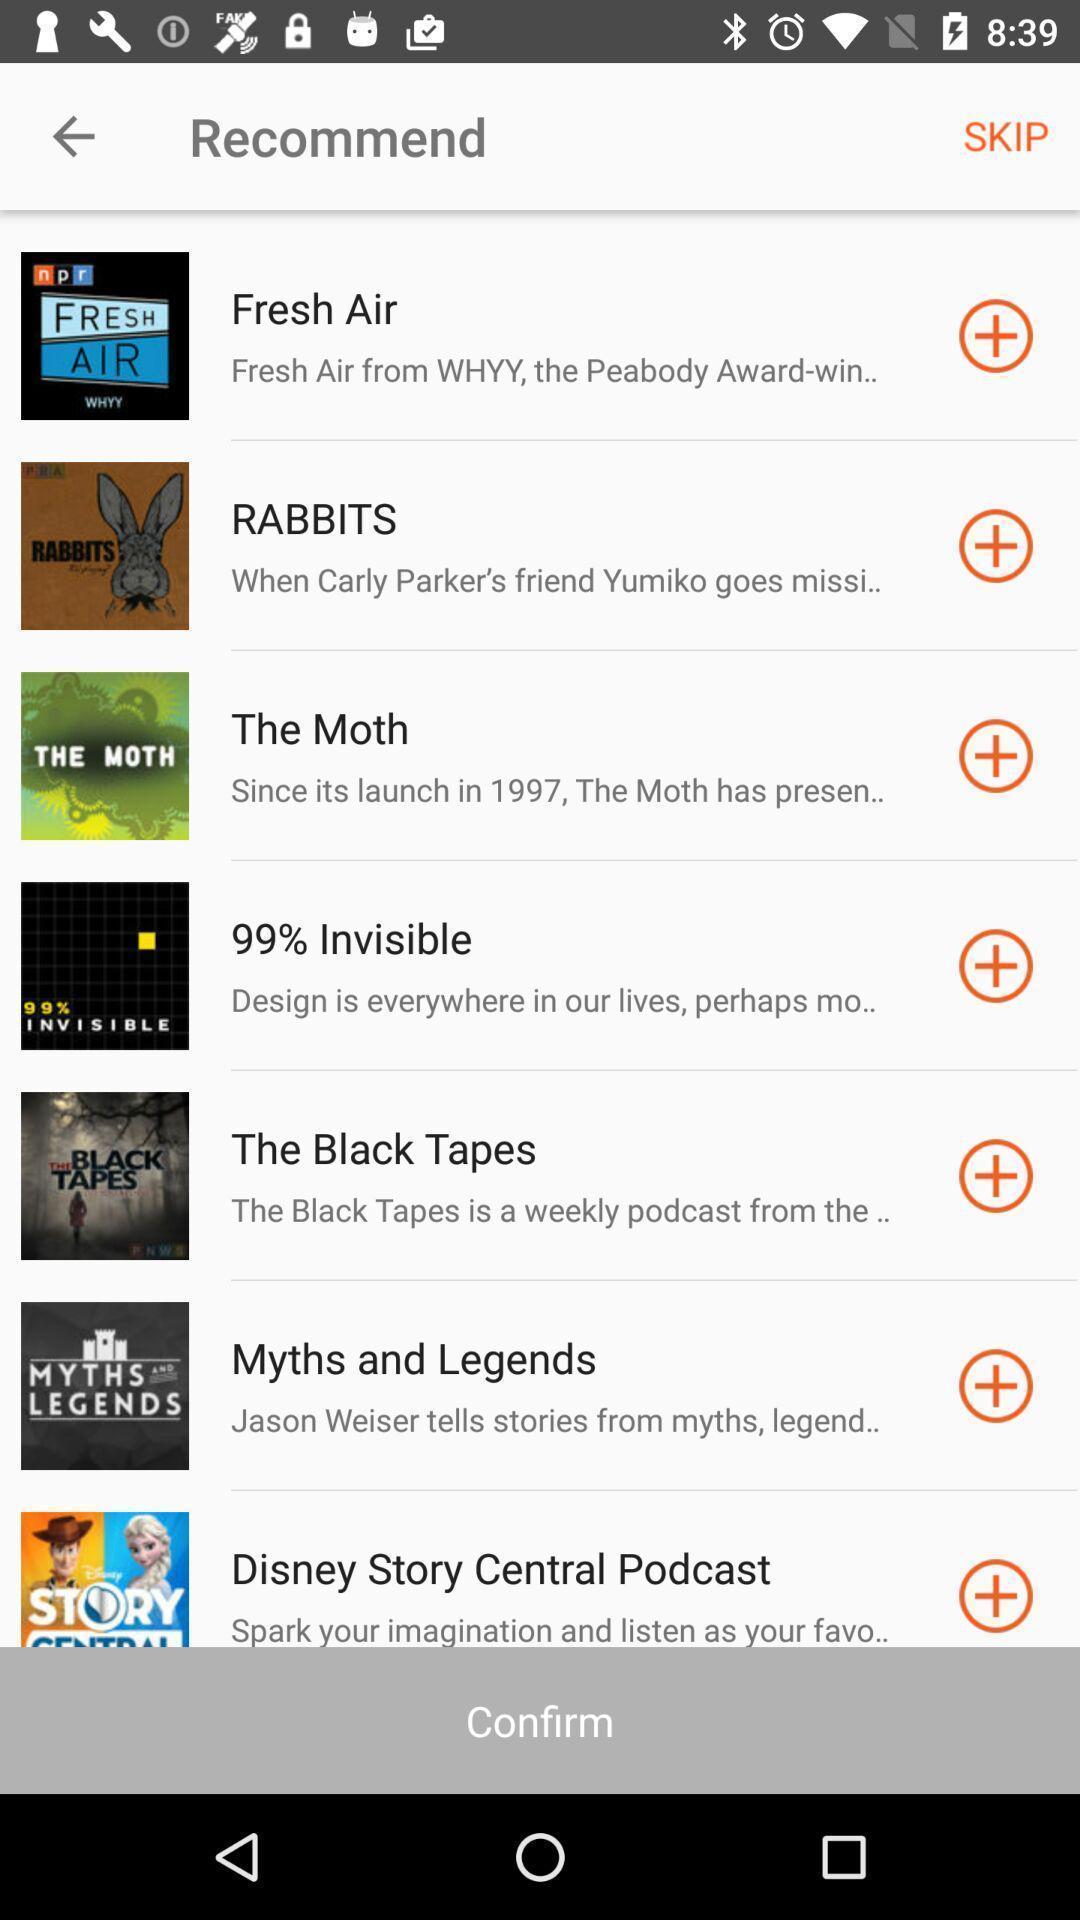Tell me what you see in this picture. Screen displaying list of recommended apps. 